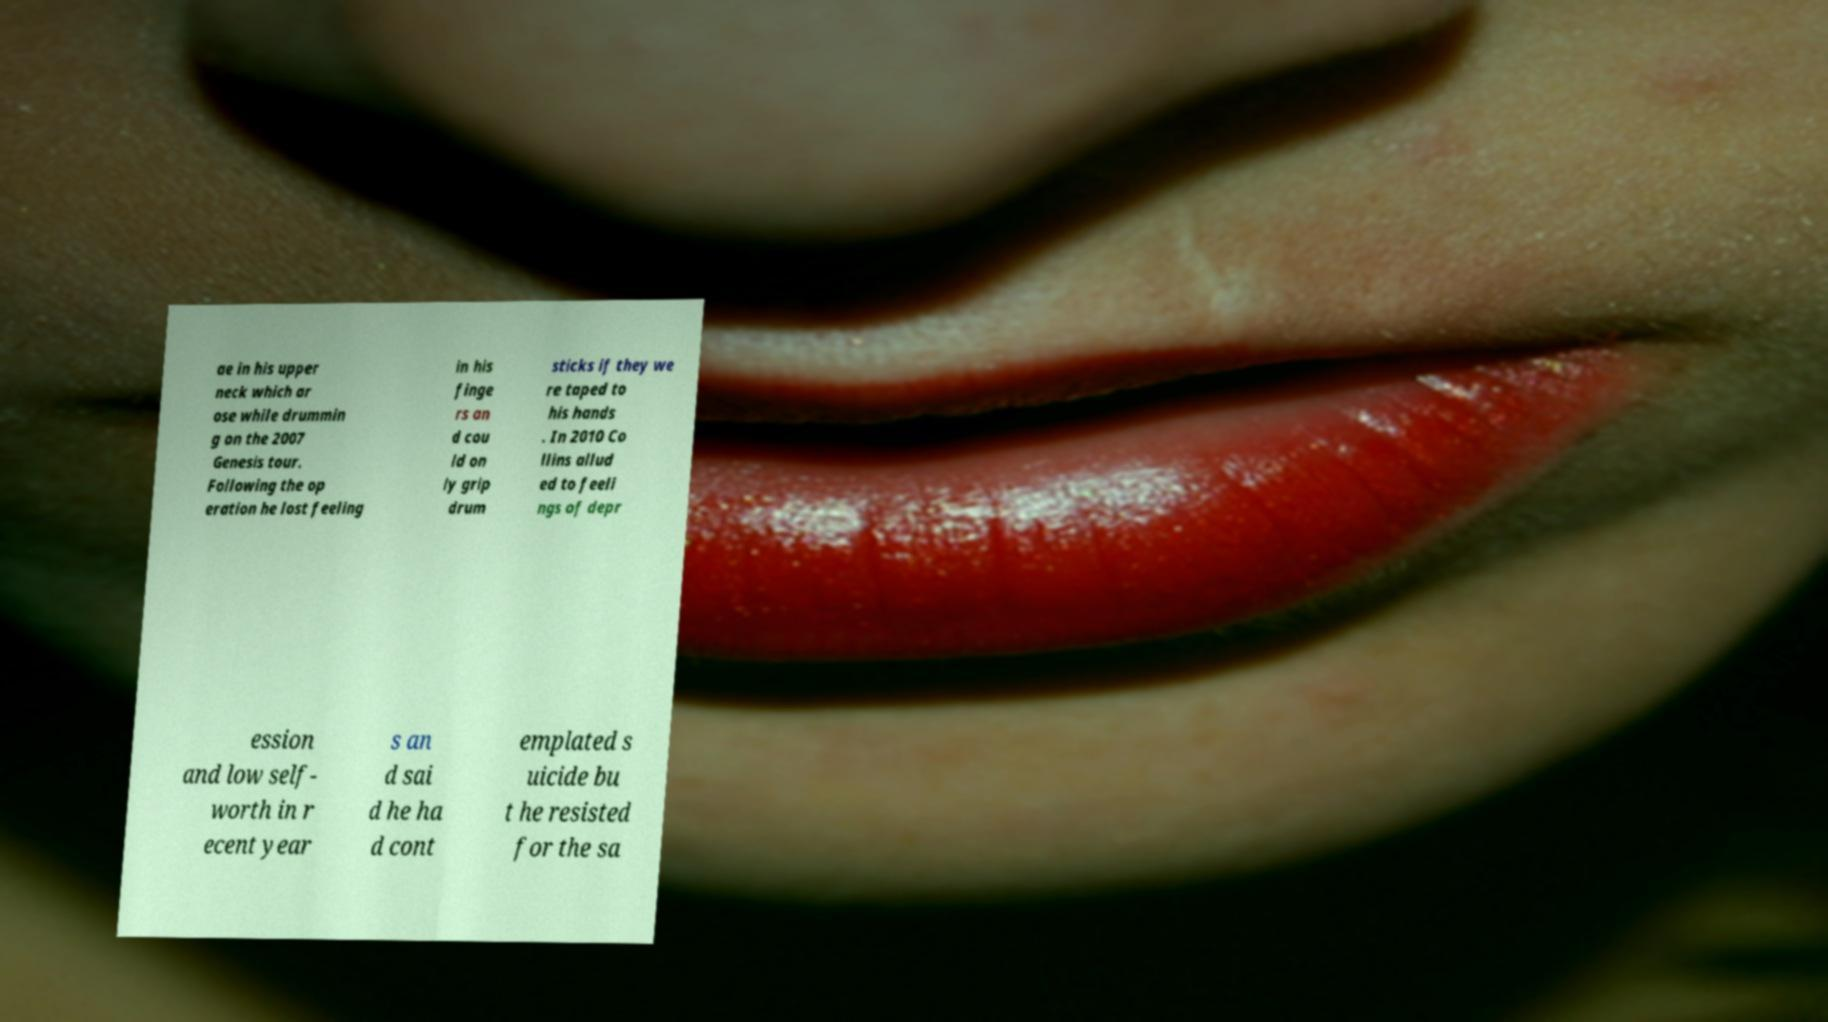Please identify and transcribe the text found in this image. ae in his upper neck which ar ose while drummin g on the 2007 Genesis tour. Following the op eration he lost feeling in his finge rs an d cou ld on ly grip drum sticks if they we re taped to his hands . In 2010 Co llins allud ed to feeli ngs of depr ession and low self- worth in r ecent year s an d sai d he ha d cont emplated s uicide bu t he resisted for the sa 